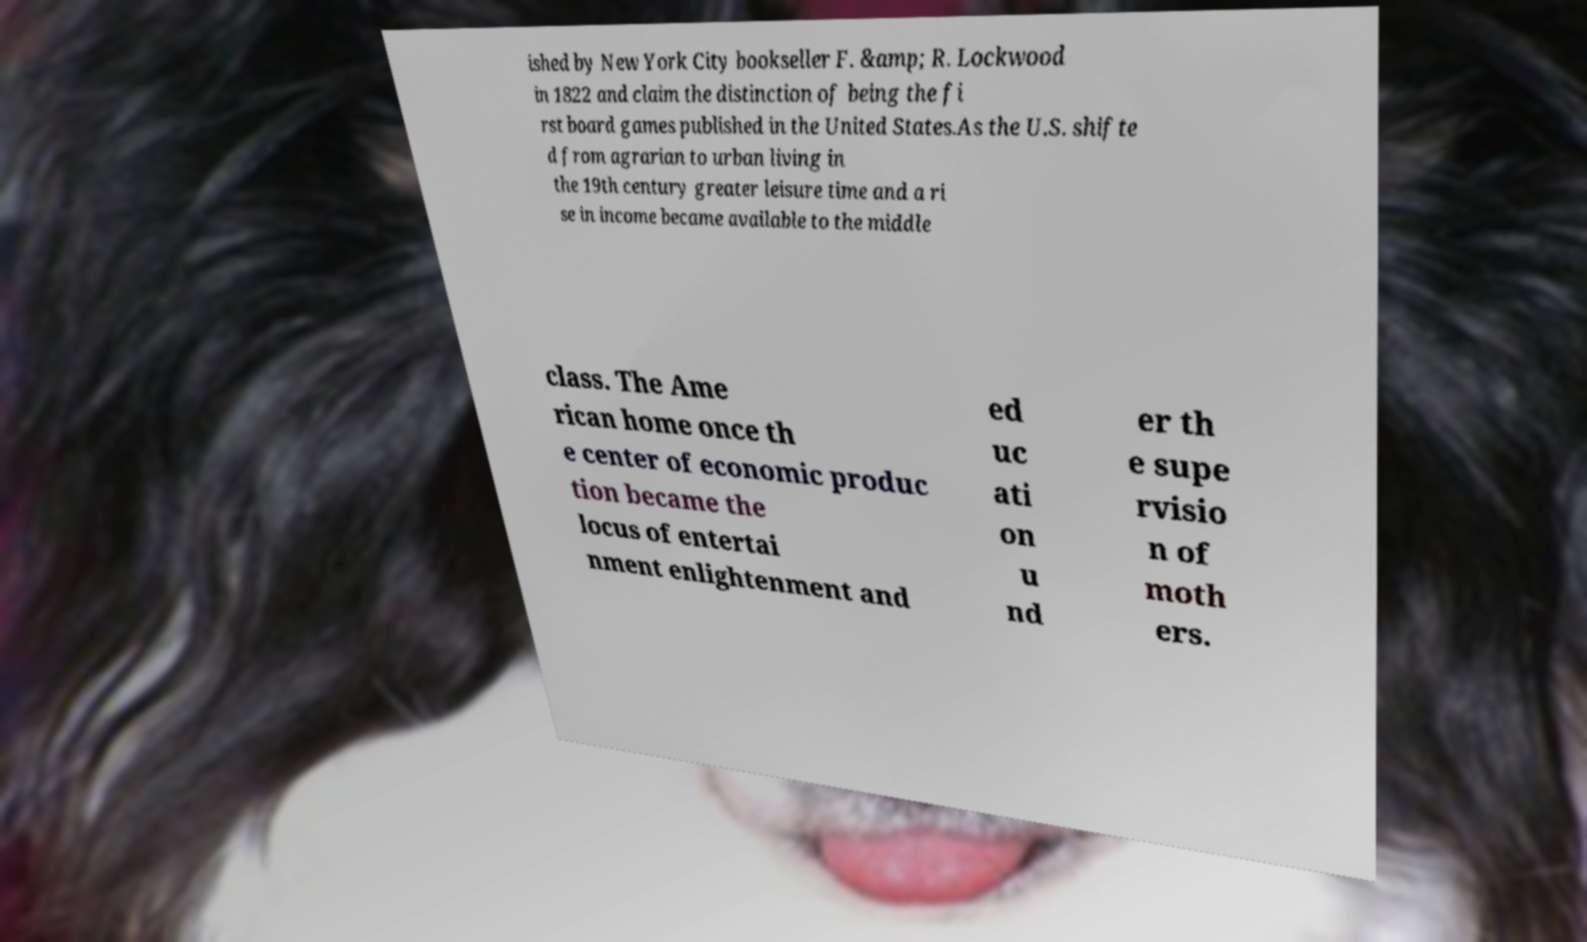There's text embedded in this image that I need extracted. Can you transcribe it verbatim? ished by New York City bookseller F. &amp; R. Lockwood in 1822 and claim the distinction of being the fi rst board games published in the United States.As the U.S. shifte d from agrarian to urban living in the 19th century greater leisure time and a ri se in income became available to the middle class. The Ame rican home once th e center of economic produc tion became the locus of entertai nment enlightenment and ed uc ati on u nd er th e supe rvisio n of moth ers. 